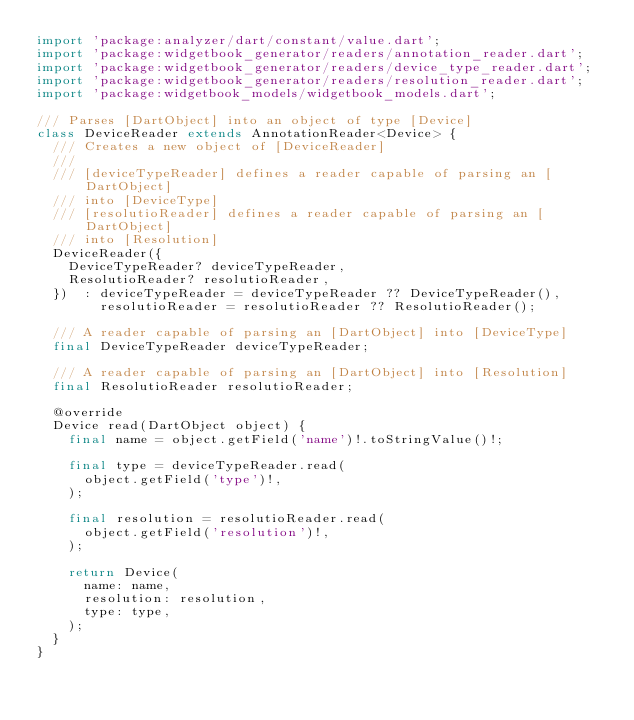<code> <loc_0><loc_0><loc_500><loc_500><_Dart_>import 'package:analyzer/dart/constant/value.dart';
import 'package:widgetbook_generator/readers/annotation_reader.dart';
import 'package:widgetbook_generator/readers/device_type_reader.dart';
import 'package:widgetbook_generator/readers/resolution_reader.dart';
import 'package:widgetbook_models/widgetbook_models.dart';

/// Parses [DartObject] into an object of type [Device]
class DeviceReader extends AnnotationReader<Device> {
  /// Creates a new object of [DeviceReader]
  ///
  /// [deviceTypeReader] defines a reader capable of parsing an [DartObject]
  /// into [DeviceType]
  /// [resolutioReader] defines a reader capable of parsing an [DartObject]
  /// into [Resolution]
  DeviceReader({
    DeviceTypeReader? deviceTypeReader,
    ResolutioReader? resolutioReader,
  })  : deviceTypeReader = deviceTypeReader ?? DeviceTypeReader(),
        resolutioReader = resolutioReader ?? ResolutioReader();

  /// A reader capable of parsing an [DartObject] into [DeviceType]
  final DeviceTypeReader deviceTypeReader;

  /// A reader capable of parsing an [DartObject] into [Resolution]
  final ResolutioReader resolutioReader;

  @override
  Device read(DartObject object) {
    final name = object.getField('name')!.toStringValue()!;

    final type = deviceTypeReader.read(
      object.getField('type')!,
    );

    final resolution = resolutioReader.read(
      object.getField('resolution')!,
    );

    return Device(
      name: name,
      resolution: resolution,
      type: type,
    );
  }
}
</code> 